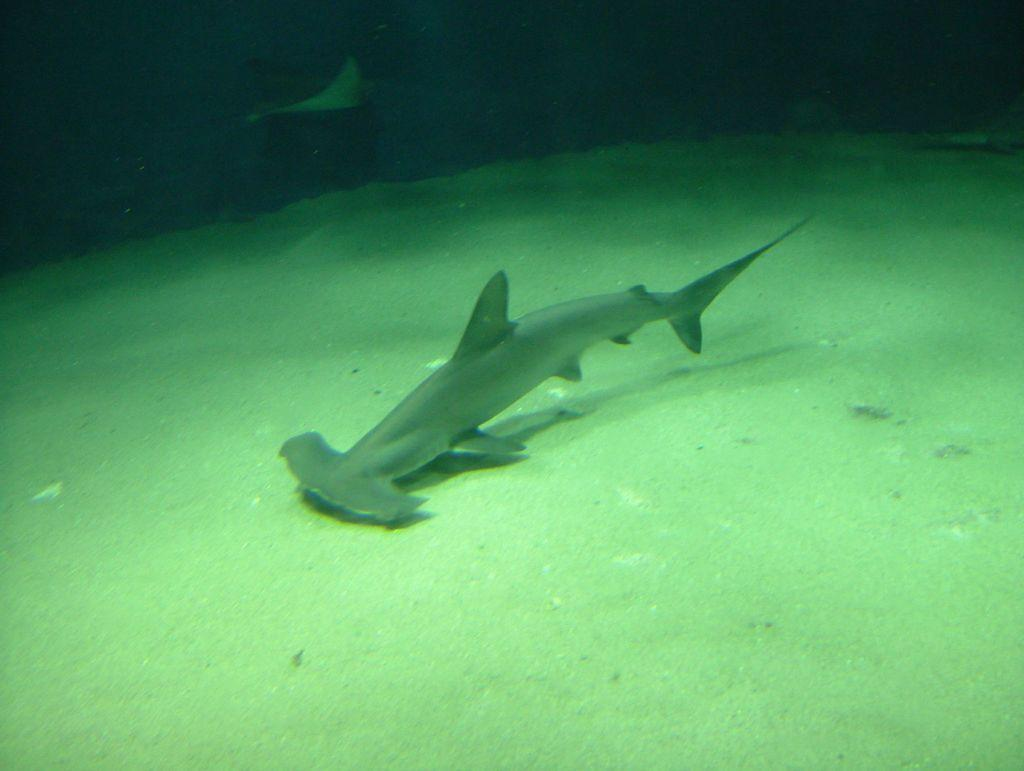What type of animal can be seen in the water in the image? There is a fish in the water in the image. What color is the floor in the image? The floor is green. What color is the background in the image? The background is black. Where is the mailbox located in the image? There is no mailbox present in the image. What type of plants can be seen in the garden in the image? There is no garden present in the image. 